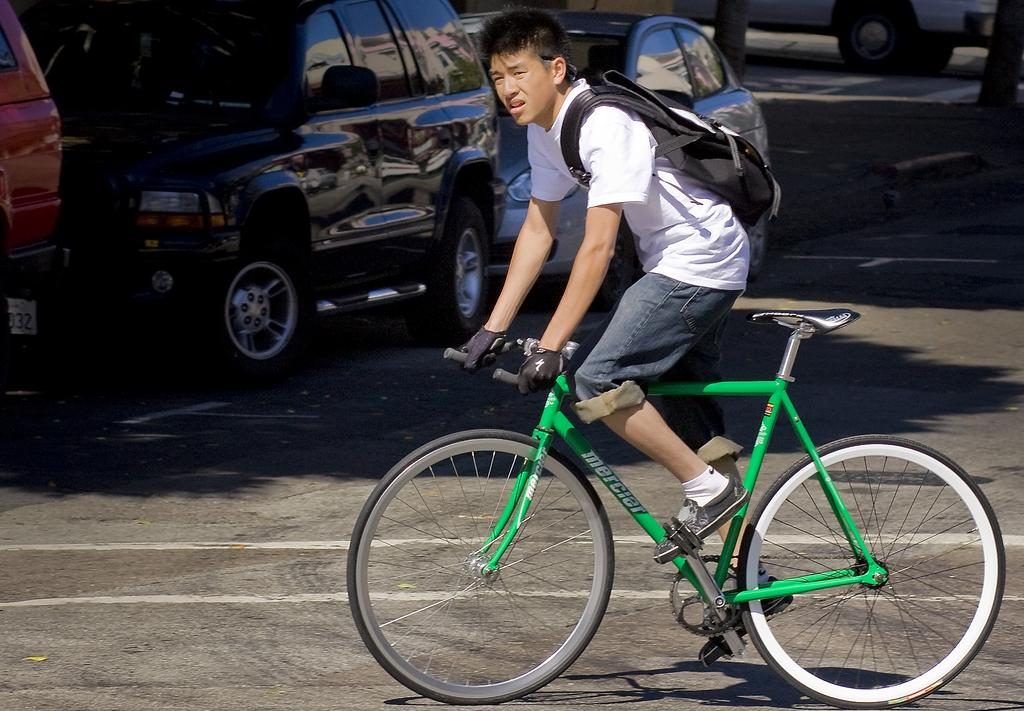Who is the main subject in the image? There is a boy in the image. What is the boy wearing? The boy is wearing a bag and gloves. What activity is the boy engaged in? The boy is riding a cycle. Where is the cycle located? The cycle is on the road. What can be seen in the background of the image? There are vehicles visible in the background. What type of mint is growing on the side of the road in the image? There is no mint growing on the side of the road in the image. 